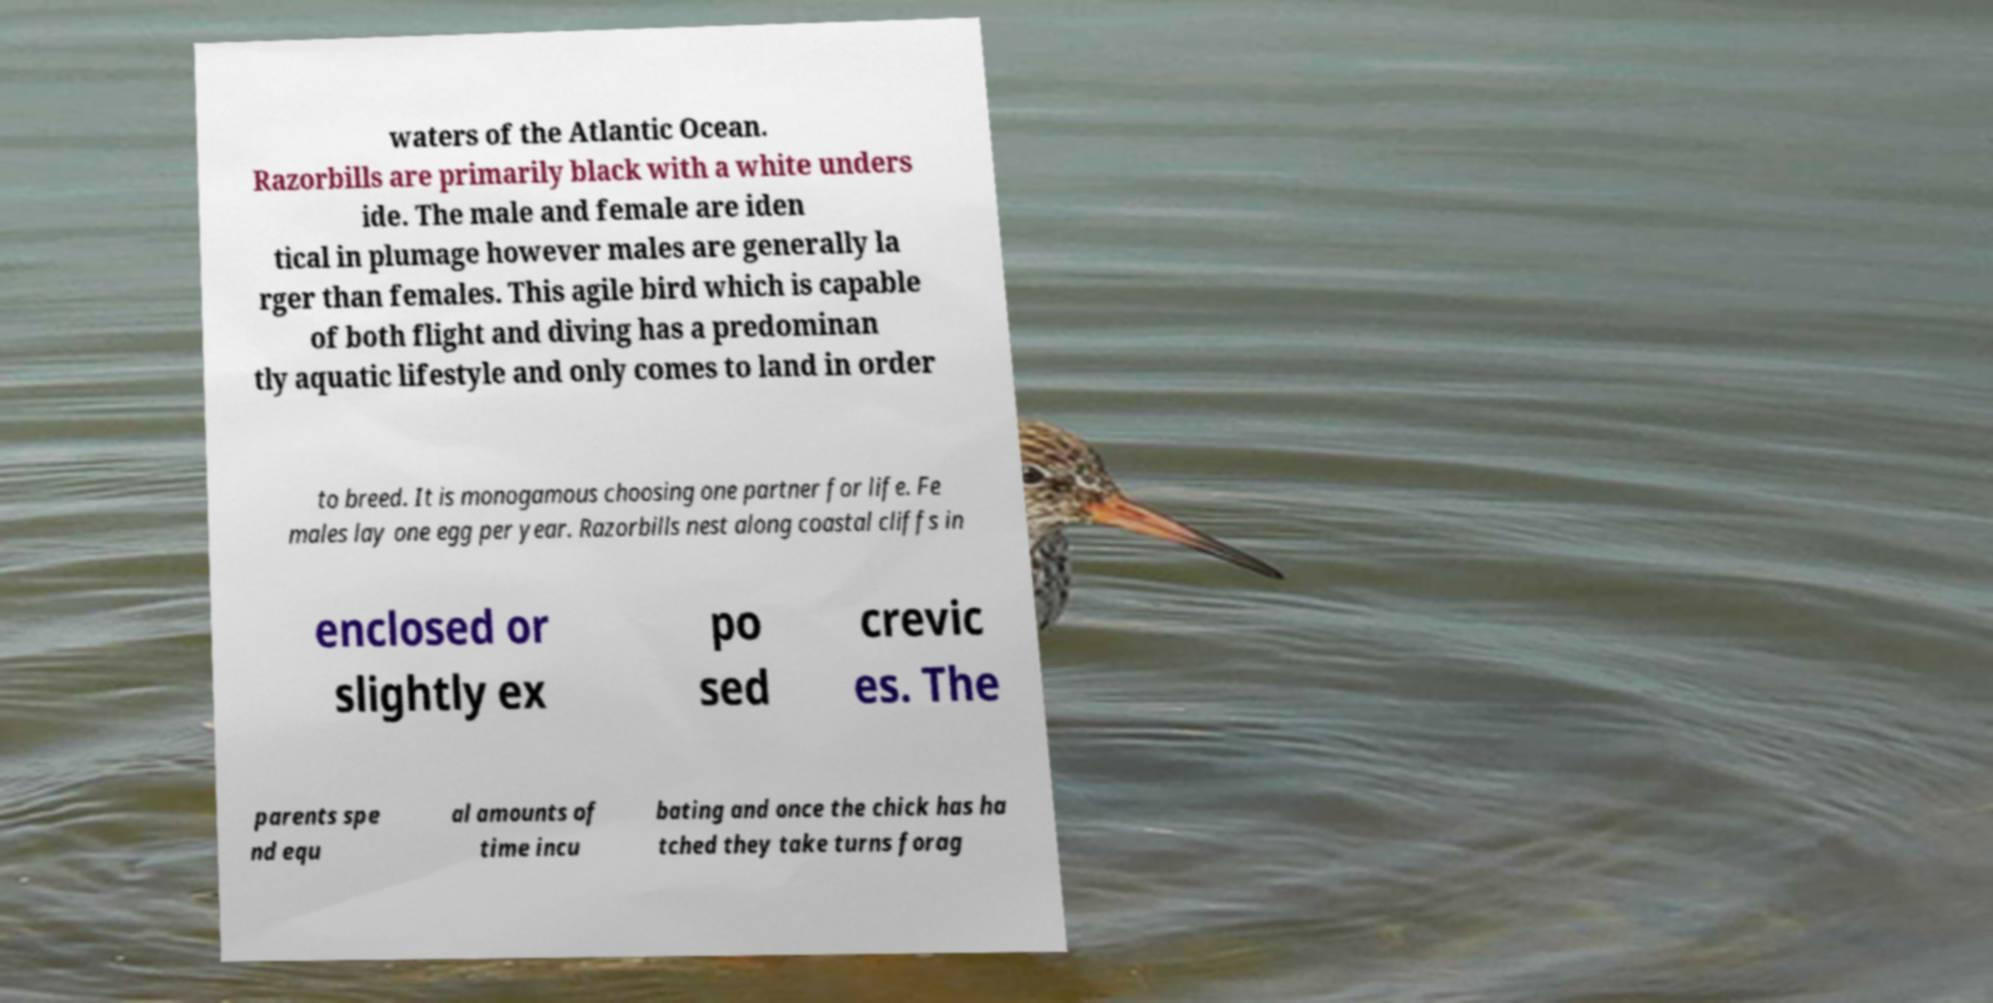For documentation purposes, I need the text within this image transcribed. Could you provide that? waters of the Atlantic Ocean. Razorbills are primarily black with a white unders ide. The male and female are iden tical in plumage however males are generally la rger than females. This agile bird which is capable of both flight and diving has a predominan tly aquatic lifestyle and only comes to land in order to breed. It is monogamous choosing one partner for life. Fe males lay one egg per year. Razorbills nest along coastal cliffs in enclosed or slightly ex po sed crevic es. The parents spe nd equ al amounts of time incu bating and once the chick has ha tched they take turns forag 